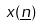<formula> <loc_0><loc_0><loc_500><loc_500>x ( \underline { n } )</formula> 